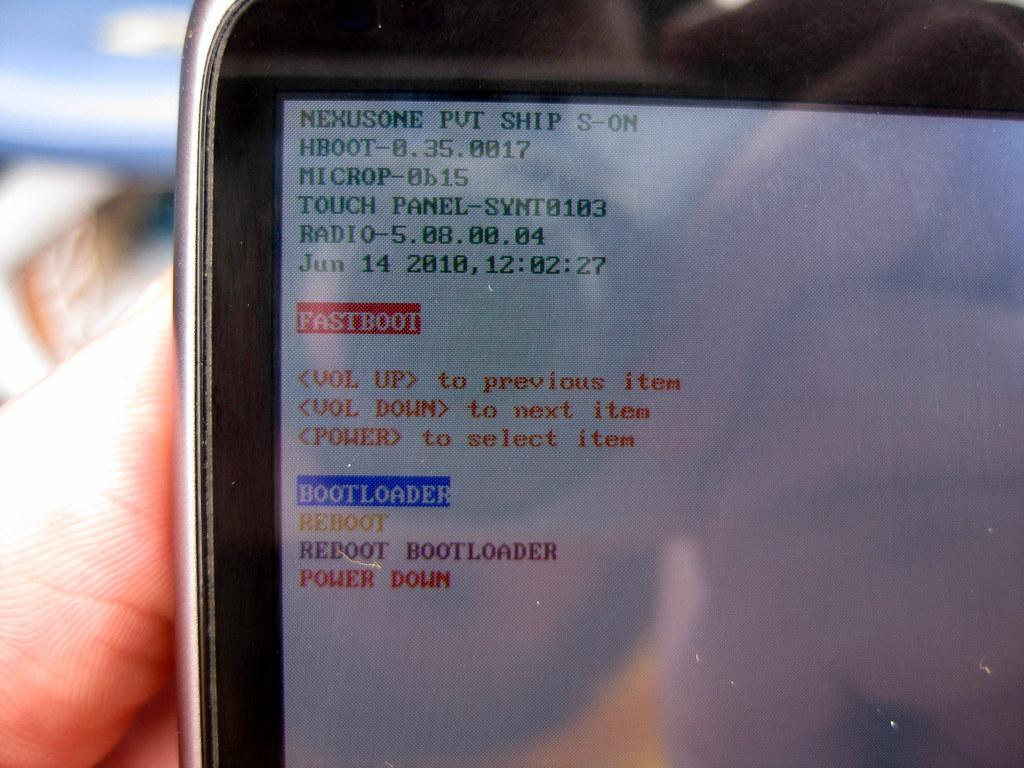<image>
Describe the image concisely. A device screen contains the words "bootloader" and "reboot" among other menu items. 